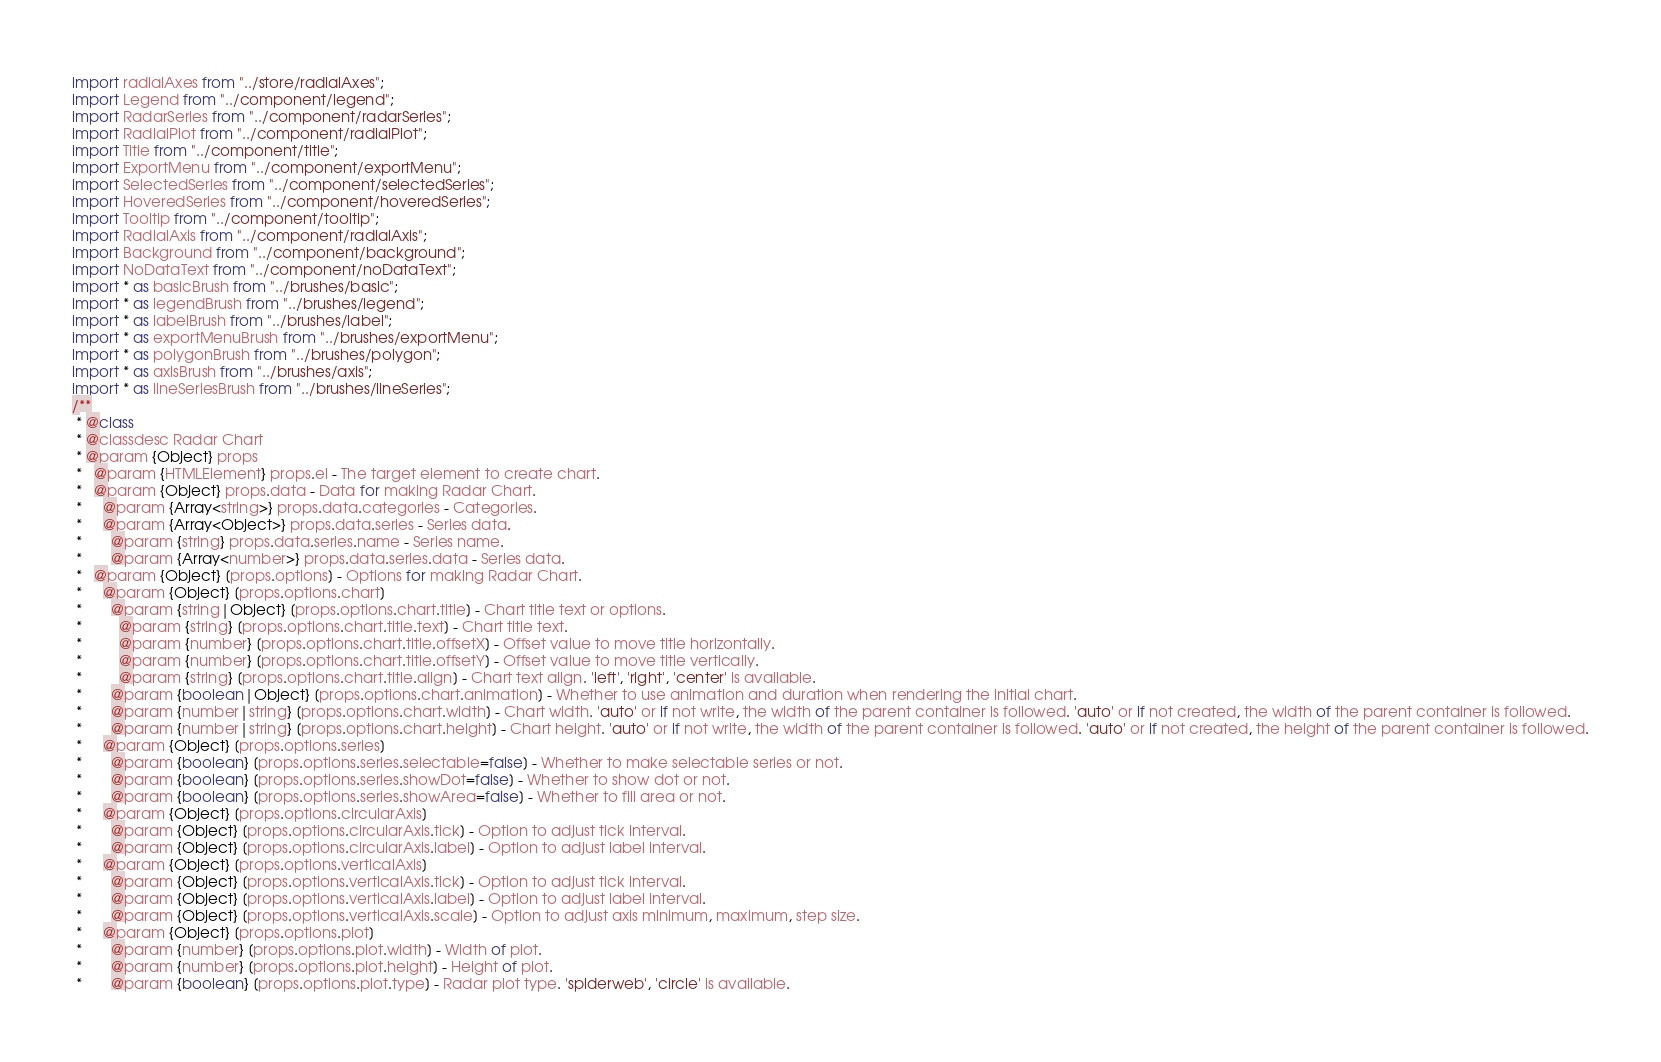<code> <loc_0><loc_0><loc_500><loc_500><_JavaScript_>import radialAxes from "../store/radialAxes";
import Legend from "../component/legend";
import RadarSeries from "../component/radarSeries";
import RadialPlot from "../component/radialPlot";
import Title from "../component/title";
import ExportMenu from "../component/exportMenu";
import SelectedSeries from "../component/selectedSeries";
import HoveredSeries from "../component/hoveredSeries";
import Tooltip from "../component/tooltip";
import RadialAxis from "../component/radialAxis";
import Background from "../component/background";
import NoDataText from "../component/noDataText";
import * as basicBrush from "../brushes/basic";
import * as legendBrush from "../brushes/legend";
import * as labelBrush from "../brushes/label";
import * as exportMenuBrush from "../brushes/exportMenu";
import * as polygonBrush from "../brushes/polygon";
import * as axisBrush from "../brushes/axis";
import * as lineSeriesBrush from "../brushes/lineSeries";
/**
 * @class
 * @classdesc Radar Chart
 * @param {Object} props
 *   @param {HTMLElement} props.el - The target element to create chart.
 *   @param {Object} props.data - Data for making Radar Chart.
 *     @param {Array<string>} props.data.categories - Categories.
 *     @param {Array<Object>} props.data.series - Series data.
 *       @param {string} props.data.series.name - Series name.
 *       @param {Array<number>} props.data.series.data - Series data.
 *   @param {Object} [props.options] - Options for making Radar Chart.
 *     @param {Object} [props.options.chart]
 *       @param {string|Object} [props.options.chart.title] - Chart title text or options.
 *         @param {string} [props.options.chart.title.text] - Chart title text.
 *         @param {number} [props.options.chart.title.offsetX] - Offset value to move title horizontally.
 *         @param {number} [props.options.chart.title.offsetY] - Offset value to move title vertically.
 *         @param {string} [props.options.chart.title.align] - Chart text align. 'left', 'right', 'center' is available.
 *       @param {boolean|Object} [props.options.chart.animation] - Whether to use animation and duration when rendering the initial chart.
 *       @param {number|string} [props.options.chart.width] - Chart width. 'auto' or if not write, the width of the parent container is followed. 'auto' or if not created, the width of the parent container is followed.
 *       @param {number|string} [props.options.chart.height] - Chart height. 'auto' or if not write, the width of the parent container is followed. 'auto' or if not created, the height of the parent container is followed.
 *     @param {Object} [props.options.series]
 *       @param {boolean} [props.options.series.selectable=false] - Whether to make selectable series or not.
 *       @param {boolean} [props.options.series.showDot=false] - Whether to show dot or not.
 *       @param {boolean} [props.options.series.showArea=false] - Whether to fill area or not.
 *     @param {Object} [props.options.circularAxis]
 *       @param {Object} [props.options.circularAxis.tick] - Option to adjust tick interval.
 *       @param {Object} [props.options.circularAxis.label] - Option to adjust label interval.
 *     @param {Object} [props.options.verticalAxis]
 *       @param {Object} [props.options.verticalAxis.tick] - Option to adjust tick interval.
 *       @param {Object} [props.options.verticalAxis.label] - Option to adjust label interval.
 *       @param {Object} [props.options.verticalAxis.scale] - Option to adjust axis minimum, maximum, step size.
 *     @param {Object} [props.options.plot]
 *       @param {number} [props.options.plot.width] - Width of plot.
 *       @param {number} [props.options.plot.height] - Height of plot.
 *       @param {boolean} [props.options.plot.type] - Radar plot type. 'spiderweb', 'circle' is available.</code> 